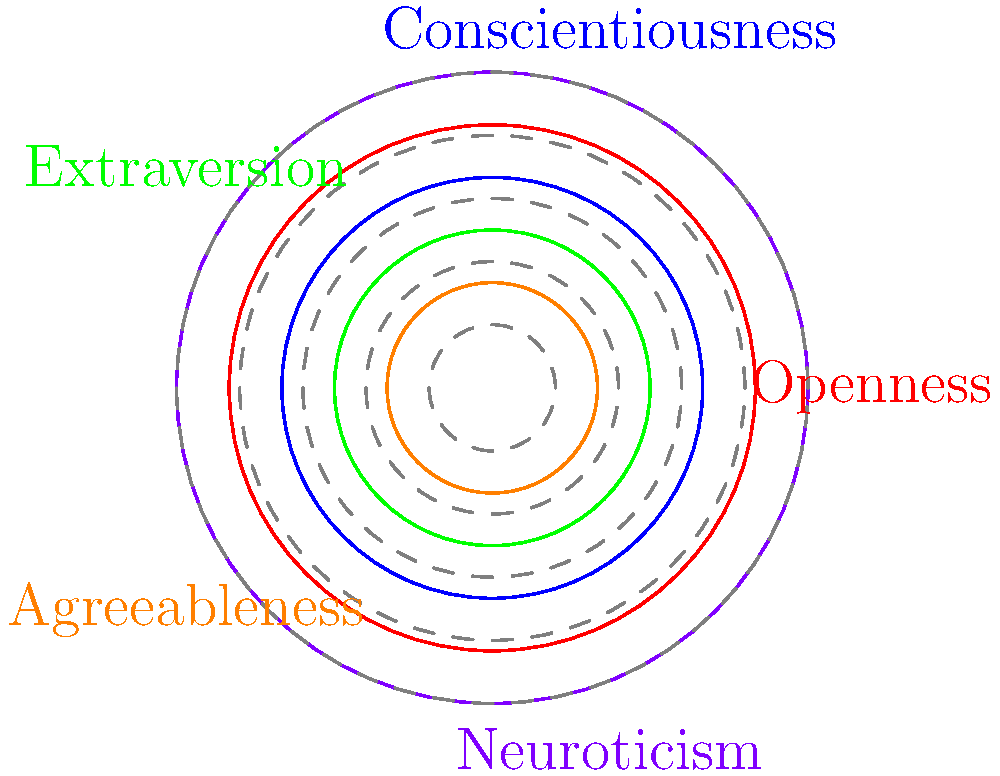Based on the radar chart representing the distribution of personality types in a population, which personality trait is most prevalent, and what percentage of the population exhibits this trait? To determine the most prevalent personality trait and its percentage:

1. Identify the traits represented: Openness, Conscientiousness, Extraversion, Agreeableness, and Neuroticism.

2. Compare the relative sizes of each segment:
   - Openness: Medium-large
   - Conscientiousness: Medium
   - Extraversion: Medium-small
   - Agreeableness: Small
   - Neuroticism: Largest

3. Neuroticism has the largest segment, indicating it's the most prevalent trait.

4. Estimate the percentage:
   - The chart is divided into 5 concentric circles, each representing 20% (100% / 5 = 20%).
   - The Neuroticism segment extends slightly beyond the third circle from the center.
   - This indicates approximately 30% of the population (3 * 10% = 30%).

Therefore, Neuroticism is the most prevalent trait, exhibited by approximately 30% of the population.
Answer: Neuroticism, 30% 